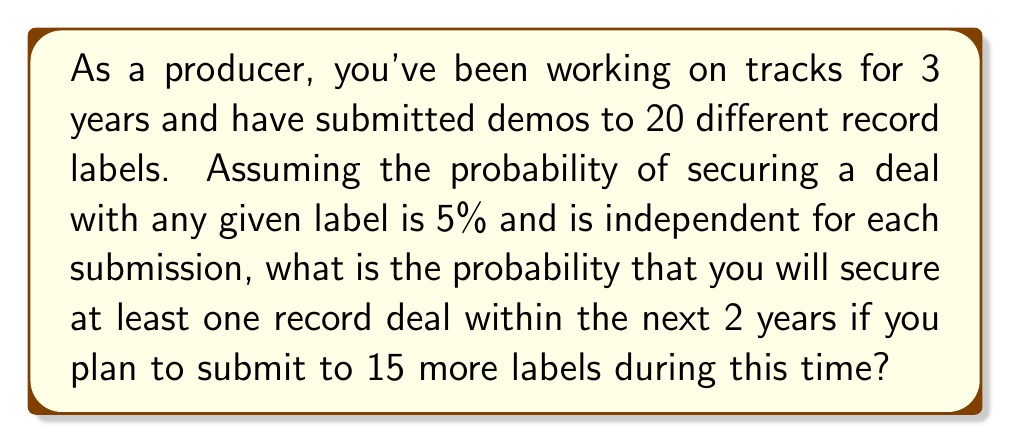Can you solve this math problem? Let's approach this step-by-step:

1) First, we need to calculate the probability of not securing a deal with a single label submission:
   $P(\text{no deal}) = 1 - P(\text{deal}) = 1 - 0.05 = 0.95$

2) Now, we want to find the probability of not securing a deal with any of the 15 new submissions. Since each submission is independent, we can use the multiplication rule:
   $P(\text{no deal in 15 submissions}) = 0.95^{15}$

3) The probability of securing at least one deal is the complement of not securing any deals:
   $P(\text{at least one deal}) = 1 - P(\text{no deal in 15 submissions})$

4) Let's calculate this:
   $$\begin{aligned}
   P(\text{at least one deal}) &= 1 - 0.95^{15} \\
   &= 1 - 0.4633 \\
   &= 0.5367
   \end{aligned}$$

5) Converting to a percentage:
   $0.5367 \times 100\% = 53.67\%$

Therefore, the probability of securing at least one record deal within the next 2 years is approximately 53.67%.
Answer: 53.67% 